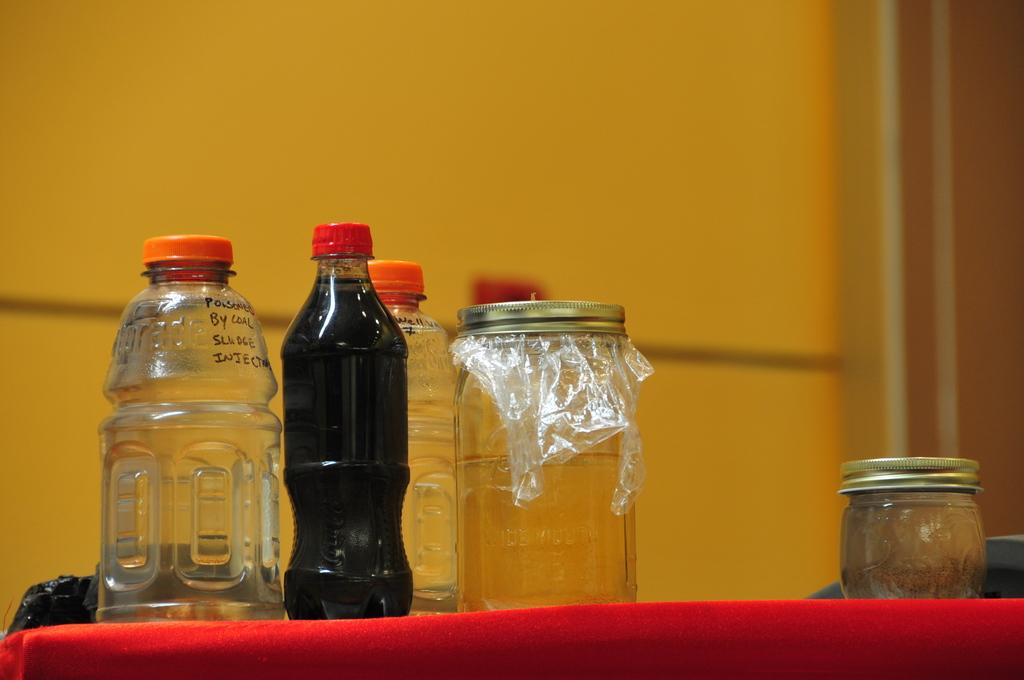Provide a one-sentence caption for the provided image. Some jars and bottles, one of which says "poisoned by coal sludge injection". 